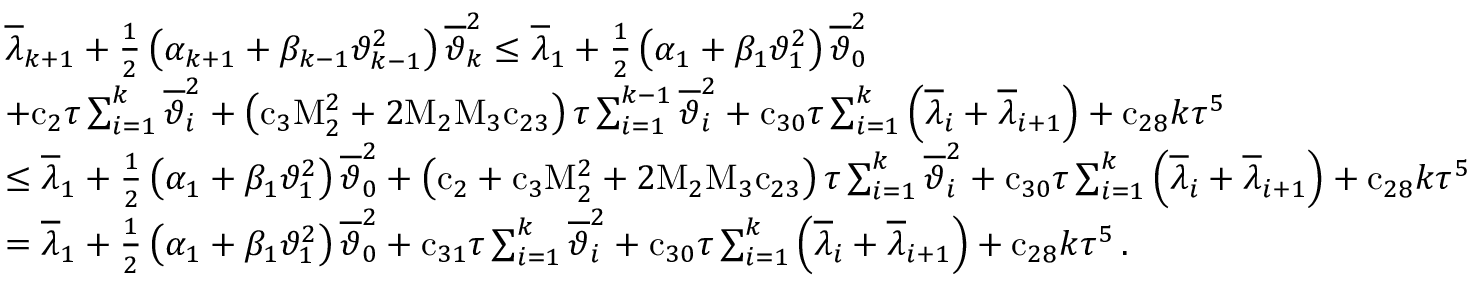Convert formula to latex. <formula><loc_0><loc_0><loc_500><loc_500>\begin{array} { r l } & { { \overline { \lambda } } _ { k + 1 } + \frac { 1 } { 2 } \left ( { \alpha } _ { k + 1 } + { \beta } _ { k - 1 } { \vartheta } _ { k - 1 } ^ { 2 } \right ) { \overline { \vartheta } } _ { k } ^ { 2 } \leq { \overline { \lambda } } _ { 1 } + \frac { 1 } { 2 } \left ( { \alpha } _ { 1 } + { \beta } _ { 1 } { \vartheta } _ { 1 } ^ { 2 } \right ) { \overline { \vartheta } } _ { 0 } ^ { 2 } } \\ & { + { c } _ { 2 } { \tau } \sum _ { i = 1 } ^ { k } { { \overline { \vartheta } } _ { i } ^ { 2 } } + \left ( { c } _ { 3 } { M } _ { 2 } ^ { 2 } + { 2 } { M } _ { 2 } { M } _ { 3 } { c } _ { 2 3 } \right ) { \tau } \sum _ { i = 1 } ^ { k - 1 } { { \overline { \vartheta } } _ { i } ^ { 2 } } + { c } _ { 3 0 } { \tau } \sum _ { i = 1 } ^ { k } { \left ( { \overline { \lambda } } _ { i } + { \overline { \lambda } } _ { i + 1 } \right ) } + { c } _ { 2 8 } { k } { \tau } ^ { 5 } } \\ & { \leq { \overline { \lambda } } _ { 1 } + \frac { 1 } { 2 } \left ( { \alpha } _ { 1 } + { \beta } _ { 1 } { \vartheta } _ { 1 } ^ { 2 } \right ) { \overline { \vartheta } } _ { 0 } ^ { 2 } + \left ( { c } _ { 2 } + { c } _ { 3 } { M } _ { 2 } ^ { 2 } + { 2 } { M } _ { 2 } { M } _ { 3 } { c } _ { 2 3 } \right ) { \tau } \sum _ { i = 1 } ^ { k } { { \overline { \vartheta } } _ { i } ^ { 2 } } + { c } _ { 3 0 } { \tau } \sum _ { i = 1 } ^ { k } { \left ( { \overline { \lambda } } _ { i } + { \overline { \lambda } } _ { i + 1 } \right ) } + { c } _ { 2 8 } { k } { \tau } ^ { 5 } } \\ & { = { \overline { \lambda } } _ { 1 } + \frac { 1 } { 2 } \left ( { \alpha } _ { 1 } + { \beta } _ { 1 } { \vartheta } _ { 1 } ^ { 2 } \right ) { \overline { \vartheta } } _ { 0 } ^ { 2 } + { c } _ { 3 1 } { \tau } \sum _ { i = 1 } ^ { k } { { \overline { \vartheta } } _ { i } ^ { 2 } } + { c } _ { 3 0 } { \tau } \sum _ { i = 1 } ^ { k } { \left ( { \overline { \lambda } } _ { i } + { \overline { \lambda } } _ { i + 1 } \right ) } + { c } _ { 2 8 } { k } { \tau } ^ { 5 } \, . } \end{array}</formula> 